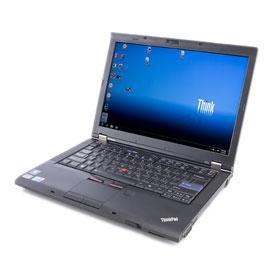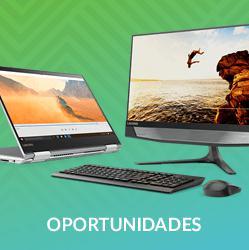The first image is the image on the left, the second image is the image on the right. Considering the images on both sides, is "There are more computers in the image on the left." valid? Answer yes or no. No. 